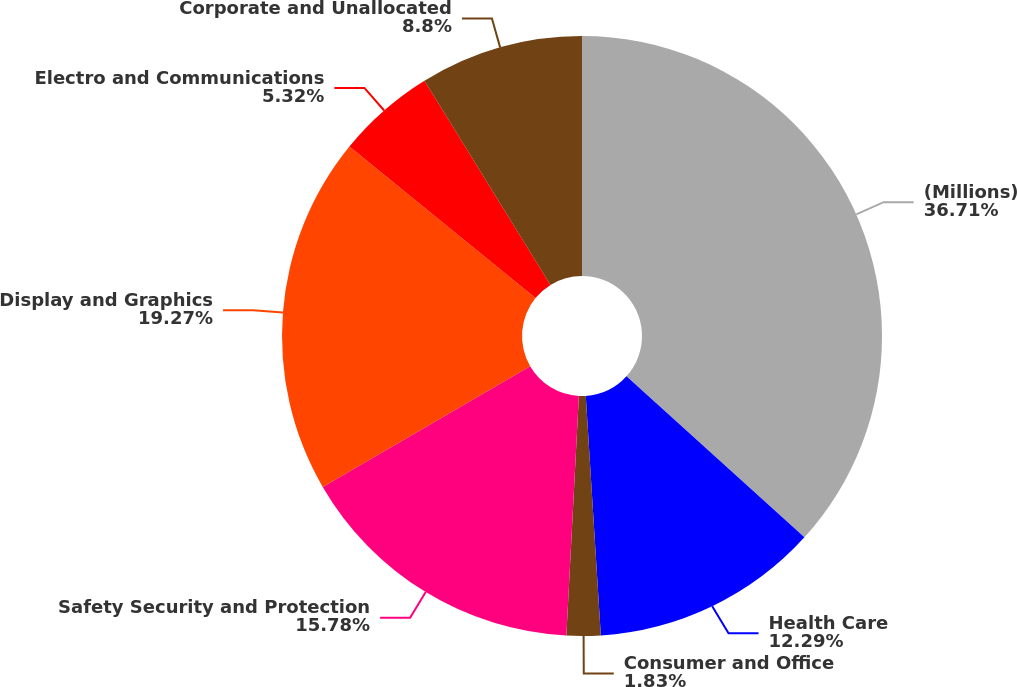Convert chart. <chart><loc_0><loc_0><loc_500><loc_500><pie_chart><fcel>(Millions)<fcel>Health Care<fcel>Consumer and Office<fcel>Safety Security and Protection<fcel>Display and Graphics<fcel>Electro and Communications<fcel>Corporate and Unallocated<nl><fcel>36.71%<fcel>12.29%<fcel>1.83%<fcel>15.78%<fcel>19.27%<fcel>5.32%<fcel>8.8%<nl></chart> 